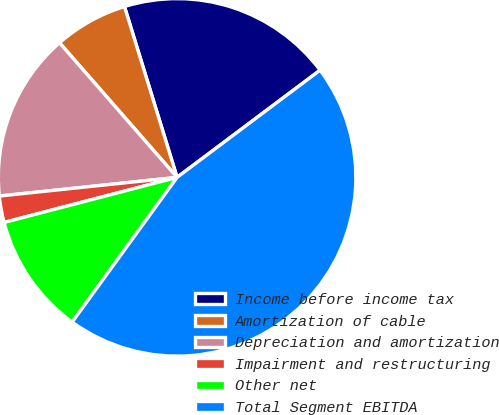Convert chart. <chart><loc_0><loc_0><loc_500><loc_500><pie_chart><fcel>Income before income tax<fcel>Amortization of cable<fcel>Depreciation and amortization<fcel>Impairment and restructuring<fcel>Other net<fcel>Total Segment EBITDA<nl><fcel>19.52%<fcel>6.67%<fcel>15.24%<fcel>2.39%<fcel>10.96%<fcel>45.22%<nl></chart> 